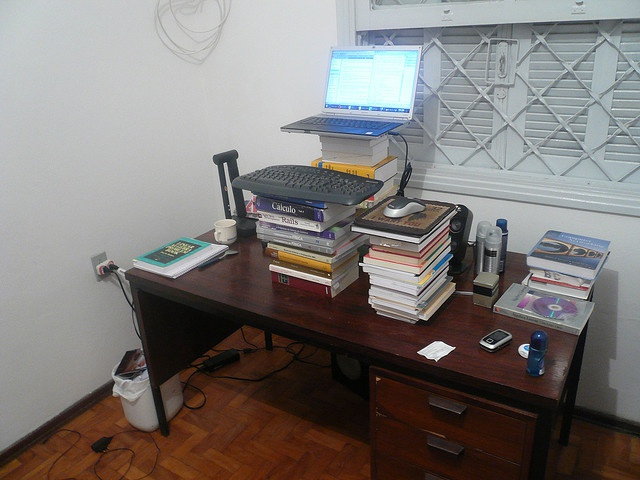Describe the objects in this image and their specific colors. I can see book in lightgray, gray, darkgray, black, and maroon tones, laptop in lightgray, lightblue, and darkgray tones, keyboard in lightgray, gray, black, and purple tones, book in lightgray, darkgray, and gray tones, and laptop in lightgray, gray, darkgray, and blue tones in this image. 